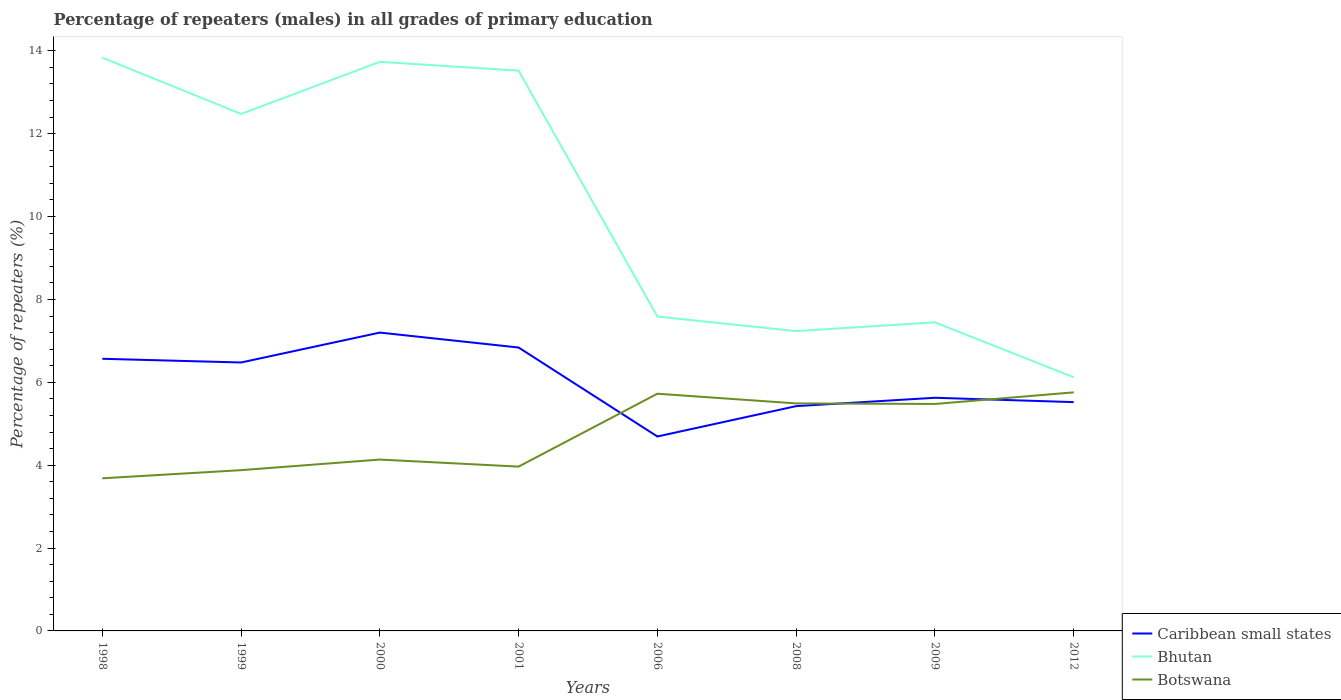How many different coloured lines are there?
Your answer should be compact. 3. Does the line corresponding to Botswana intersect with the line corresponding to Caribbean small states?
Give a very brief answer. Yes. Is the number of lines equal to the number of legend labels?
Make the answer very short. Yes. Across all years, what is the maximum percentage of repeaters (males) in Bhutan?
Keep it short and to the point. 6.12. What is the total percentage of repeaters (males) in Botswana in the graph?
Give a very brief answer. -1.79. What is the difference between the highest and the second highest percentage of repeaters (males) in Botswana?
Your answer should be very brief. 2.07. What is the difference between the highest and the lowest percentage of repeaters (males) in Caribbean small states?
Keep it short and to the point. 4. Is the percentage of repeaters (males) in Botswana strictly greater than the percentage of repeaters (males) in Bhutan over the years?
Provide a succinct answer. Yes. What is the difference between two consecutive major ticks on the Y-axis?
Provide a succinct answer. 2. Are the values on the major ticks of Y-axis written in scientific E-notation?
Offer a terse response. No. Does the graph contain any zero values?
Make the answer very short. No. Does the graph contain grids?
Make the answer very short. No. How many legend labels are there?
Ensure brevity in your answer.  3. How are the legend labels stacked?
Make the answer very short. Vertical. What is the title of the graph?
Keep it short and to the point. Percentage of repeaters (males) in all grades of primary education. Does "Kiribati" appear as one of the legend labels in the graph?
Provide a short and direct response. No. What is the label or title of the Y-axis?
Ensure brevity in your answer.  Percentage of repeaters (%). What is the Percentage of repeaters (%) of Caribbean small states in 1998?
Offer a terse response. 6.57. What is the Percentage of repeaters (%) of Bhutan in 1998?
Your answer should be very brief. 13.84. What is the Percentage of repeaters (%) in Botswana in 1998?
Keep it short and to the point. 3.68. What is the Percentage of repeaters (%) in Caribbean small states in 1999?
Your answer should be very brief. 6.48. What is the Percentage of repeaters (%) of Bhutan in 1999?
Ensure brevity in your answer.  12.48. What is the Percentage of repeaters (%) in Botswana in 1999?
Your answer should be very brief. 3.88. What is the Percentage of repeaters (%) in Caribbean small states in 2000?
Your answer should be compact. 7.2. What is the Percentage of repeaters (%) of Bhutan in 2000?
Offer a terse response. 13.73. What is the Percentage of repeaters (%) in Botswana in 2000?
Keep it short and to the point. 4.14. What is the Percentage of repeaters (%) of Caribbean small states in 2001?
Keep it short and to the point. 6.84. What is the Percentage of repeaters (%) in Bhutan in 2001?
Provide a short and direct response. 13.52. What is the Percentage of repeaters (%) in Botswana in 2001?
Give a very brief answer. 3.97. What is the Percentage of repeaters (%) in Caribbean small states in 2006?
Provide a succinct answer. 4.69. What is the Percentage of repeaters (%) in Bhutan in 2006?
Give a very brief answer. 7.59. What is the Percentage of repeaters (%) in Botswana in 2006?
Your response must be concise. 5.72. What is the Percentage of repeaters (%) in Caribbean small states in 2008?
Give a very brief answer. 5.42. What is the Percentage of repeaters (%) of Bhutan in 2008?
Make the answer very short. 7.24. What is the Percentage of repeaters (%) in Botswana in 2008?
Provide a short and direct response. 5.49. What is the Percentage of repeaters (%) in Caribbean small states in 2009?
Provide a short and direct response. 5.63. What is the Percentage of repeaters (%) of Bhutan in 2009?
Provide a short and direct response. 7.45. What is the Percentage of repeaters (%) of Botswana in 2009?
Provide a short and direct response. 5.48. What is the Percentage of repeaters (%) of Caribbean small states in 2012?
Provide a short and direct response. 5.52. What is the Percentage of repeaters (%) in Bhutan in 2012?
Your answer should be compact. 6.12. What is the Percentage of repeaters (%) of Botswana in 2012?
Provide a succinct answer. 5.76. Across all years, what is the maximum Percentage of repeaters (%) of Caribbean small states?
Give a very brief answer. 7.2. Across all years, what is the maximum Percentage of repeaters (%) in Bhutan?
Your answer should be compact. 13.84. Across all years, what is the maximum Percentage of repeaters (%) of Botswana?
Provide a succinct answer. 5.76. Across all years, what is the minimum Percentage of repeaters (%) of Caribbean small states?
Make the answer very short. 4.69. Across all years, what is the minimum Percentage of repeaters (%) in Bhutan?
Your answer should be very brief. 6.12. Across all years, what is the minimum Percentage of repeaters (%) in Botswana?
Provide a short and direct response. 3.68. What is the total Percentage of repeaters (%) of Caribbean small states in the graph?
Make the answer very short. 48.35. What is the total Percentage of repeaters (%) of Bhutan in the graph?
Ensure brevity in your answer.  81.96. What is the total Percentage of repeaters (%) in Botswana in the graph?
Keep it short and to the point. 38.11. What is the difference between the Percentage of repeaters (%) in Caribbean small states in 1998 and that in 1999?
Offer a very short reply. 0.09. What is the difference between the Percentage of repeaters (%) in Bhutan in 1998 and that in 1999?
Make the answer very short. 1.36. What is the difference between the Percentage of repeaters (%) in Botswana in 1998 and that in 1999?
Your answer should be compact. -0.2. What is the difference between the Percentage of repeaters (%) of Caribbean small states in 1998 and that in 2000?
Your response must be concise. -0.63. What is the difference between the Percentage of repeaters (%) in Bhutan in 1998 and that in 2000?
Give a very brief answer. 0.1. What is the difference between the Percentage of repeaters (%) in Botswana in 1998 and that in 2000?
Ensure brevity in your answer.  -0.45. What is the difference between the Percentage of repeaters (%) in Caribbean small states in 1998 and that in 2001?
Provide a short and direct response. -0.27. What is the difference between the Percentage of repeaters (%) of Bhutan in 1998 and that in 2001?
Ensure brevity in your answer.  0.31. What is the difference between the Percentage of repeaters (%) in Botswana in 1998 and that in 2001?
Keep it short and to the point. -0.28. What is the difference between the Percentage of repeaters (%) of Caribbean small states in 1998 and that in 2006?
Make the answer very short. 1.88. What is the difference between the Percentage of repeaters (%) of Bhutan in 1998 and that in 2006?
Your answer should be very brief. 6.25. What is the difference between the Percentage of repeaters (%) in Botswana in 1998 and that in 2006?
Your answer should be compact. -2.04. What is the difference between the Percentage of repeaters (%) in Caribbean small states in 1998 and that in 2008?
Keep it short and to the point. 1.14. What is the difference between the Percentage of repeaters (%) of Bhutan in 1998 and that in 2008?
Offer a terse response. 6.6. What is the difference between the Percentage of repeaters (%) in Botswana in 1998 and that in 2008?
Give a very brief answer. -1.81. What is the difference between the Percentage of repeaters (%) of Caribbean small states in 1998 and that in 2009?
Ensure brevity in your answer.  0.94. What is the difference between the Percentage of repeaters (%) of Bhutan in 1998 and that in 2009?
Keep it short and to the point. 6.39. What is the difference between the Percentage of repeaters (%) in Botswana in 1998 and that in 2009?
Give a very brief answer. -1.79. What is the difference between the Percentage of repeaters (%) in Caribbean small states in 1998 and that in 2012?
Provide a short and direct response. 1.05. What is the difference between the Percentage of repeaters (%) of Bhutan in 1998 and that in 2012?
Provide a short and direct response. 7.71. What is the difference between the Percentage of repeaters (%) of Botswana in 1998 and that in 2012?
Make the answer very short. -2.07. What is the difference between the Percentage of repeaters (%) in Caribbean small states in 1999 and that in 2000?
Offer a very short reply. -0.72. What is the difference between the Percentage of repeaters (%) of Bhutan in 1999 and that in 2000?
Ensure brevity in your answer.  -1.26. What is the difference between the Percentage of repeaters (%) of Botswana in 1999 and that in 2000?
Offer a terse response. -0.26. What is the difference between the Percentage of repeaters (%) of Caribbean small states in 1999 and that in 2001?
Your response must be concise. -0.36. What is the difference between the Percentage of repeaters (%) of Bhutan in 1999 and that in 2001?
Make the answer very short. -1.05. What is the difference between the Percentage of repeaters (%) in Botswana in 1999 and that in 2001?
Offer a terse response. -0.09. What is the difference between the Percentage of repeaters (%) in Caribbean small states in 1999 and that in 2006?
Offer a terse response. 1.79. What is the difference between the Percentage of repeaters (%) in Bhutan in 1999 and that in 2006?
Offer a terse response. 4.89. What is the difference between the Percentage of repeaters (%) of Botswana in 1999 and that in 2006?
Provide a succinct answer. -1.84. What is the difference between the Percentage of repeaters (%) in Caribbean small states in 1999 and that in 2008?
Offer a terse response. 1.05. What is the difference between the Percentage of repeaters (%) of Bhutan in 1999 and that in 2008?
Provide a succinct answer. 5.24. What is the difference between the Percentage of repeaters (%) in Botswana in 1999 and that in 2008?
Your response must be concise. -1.61. What is the difference between the Percentage of repeaters (%) in Caribbean small states in 1999 and that in 2009?
Make the answer very short. 0.85. What is the difference between the Percentage of repeaters (%) in Bhutan in 1999 and that in 2009?
Give a very brief answer. 5.03. What is the difference between the Percentage of repeaters (%) in Botswana in 1999 and that in 2009?
Offer a terse response. -1.6. What is the difference between the Percentage of repeaters (%) of Caribbean small states in 1999 and that in 2012?
Ensure brevity in your answer.  0.96. What is the difference between the Percentage of repeaters (%) in Bhutan in 1999 and that in 2012?
Ensure brevity in your answer.  6.35. What is the difference between the Percentage of repeaters (%) in Botswana in 1999 and that in 2012?
Ensure brevity in your answer.  -1.88. What is the difference between the Percentage of repeaters (%) in Caribbean small states in 2000 and that in 2001?
Offer a very short reply. 0.36. What is the difference between the Percentage of repeaters (%) of Bhutan in 2000 and that in 2001?
Give a very brief answer. 0.21. What is the difference between the Percentage of repeaters (%) of Botswana in 2000 and that in 2001?
Your answer should be very brief. 0.17. What is the difference between the Percentage of repeaters (%) in Caribbean small states in 2000 and that in 2006?
Provide a succinct answer. 2.51. What is the difference between the Percentage of repeaters (%) of Bhutan in 2000 and that in 2006?
Offer a very short reply. 6.15. What is the difference between the Percentage of repeaters (%) in Botswana in 2000 and that in 2006?
Your answer should be very brief. -1.59. What is the difference between the Percentage of repeaters (%) of Caribbean small states in 2000 and that in 2008?
Provide a succinct answer. 1.77. What is the difference between the Percentage of repeaters (%) of Bhutan in 2000 and that in 2008?
Offer a very short reply. 6.5. What is the difference between the Percentage of repeaters (%) in Botswana in 2000 and that in 2008?
Your answer should be very brief. -1.35. What is the difference between the Percentage of repeaters (%) of Caribbean small states in 2000 and that in 2009?
Provide a succinct answer. 1.57. What is the difference between the Percentage of repeaters (%) in Bhutan in 2000 and that in 2009?
Provide a succinct answer. 6.29. What is the difference between the Percentage of repeaters (%) in Botswana in 2000 and that in 2009?
Offer a terse response. -1.34. What is the difference between the Percentage of repeaters (%) in Caribbean small states in 2000 and that in 2012?
Keep it short and to the point. 1.68. What is the difference between the Percentage of repeaters (%) in Bhutan in 2000 and that in 2012?
Make the answer very short. 7.61. What is the difference between the Percentage of repeaters (%) of Botswana in 2000 and that in 2012?
Offer a terse response. -1.62. What is the difference between the Percentage of repeaters (%) in Caribbean small states in 2001 and that in 2006?
Your response must be concise. 2.15. What is the difference between the Percentage of repeaters (%) of Bhutan in 2001 and that in 2006?
Provide a succinct answer. 5.93. What is the difference between the Percentage of repeaters (%) in Botswana in 2001 and that in 2006?
Keep it short and to the point. -1.76. What is the difference between the Percentage of repeaters (%) in Caribbean small states in 2001 and that in 2008?
Your answer should be compact. 1.41. What is the difference between the Percentage of repeaters (%) in Bhutan in 2001 and that in 2008?
Offer a very short reply. 6.29. What is the difference between the Percentage of repeaters (%) of Botswana in 2001 and that in 2008?
Offer a terse response. -1.52. What is the difference between the Percentage of repeaters (%) of Caribbean small states in 2001 and that in 2009?
Your answer should be very brief. 1.21. What is the difference between the Percentage of repeaters (%) in Bhutan in 2001 and that in 2009?
Offer a very short reply. 6.07. What is the difference between the Percentage of repeaters (%) in Botswana in 2001 and that in 2009?
Provide a succinct answer. -1.51. What is the difference between the Percentage of repeaters (%) of Caribbean small states in 2001 and that in 2012?
Ensure brevity in your answer.  1.32. What is the difference between the Percentage of repeaters (%) in Bhutan in 2001 and that in 2012?
Ensure brevity in your answer.  7.4. What is the difference between the Percentage of repeaters (%) in Botswana in 2001 and that in 2012?
Keep it short and to the point. -1.79. What is the difference between the Percentage of repeaters (%) in Caribbean small states in 2006 and that in 2008?
Offer a terse response. -0.73. What is the difference between the Percentage of repeaters (%) of Bhutan in 2006 and that in 2008?
Offer a terse response. 0.35. What is the difference between the Percentage of repeaters (%) of Botswana in 2006 and that in 2008?
Ensure brevity in your answer.  0.23. What is the difference between the Percentage of repeaters (%) of Caribbean small states in 2006 and that in 2009?
Your answer should be very brief. -0.93. What is the difference between the Percentage of repeaters (%) in Bhutan in 2006 and that in 2009?
Offer a very short reply. 0.14. What is the difference between the Percentage of repeaters (%) in Botswana in 2006 and that in 2009?
Make the answer very short. 0.25. What is the difference between the Percentage of repeaters (%) of Caribbean small states in 2006 and that in 2012?
Keep it short and to the point. -0.83. What is the difference between the Percentage of repeaters (%) of Bhutan in 2006 and that in 2012?
Your answer should be compact. 1.47. What is the difference between the Percentage of repeaters (%) in Botswana in 2006 and that in 2012?
Give a very brief answer. -0.03. What is the difference between the Percentage of repeaters (%) of Caribbean small states in 2008 and that in 2009?
Your response must be concise. -0.2. What is the difference between the Percentage of repeaters (%) in Bhutan in 2008 and that in 2009?
Offer a terse response. -0.21. What is the difference between the Percentage of repeaters (%) in Botswana in 2008 and that in 2009?
Give a very brief answer. 0.01. What is the difference between the Percentage of repeaters (%) of Caribbean small states in 2008 and that in 2012?
Your answer should be very brief. -0.1. What is the difference between the Percentage of repeaters (%) of Bhutan in 2008 and that in 2012?
Offer a terse response. 1.11. What is the difference between the Percentage of repeaters (%) in Botswana in 2008 and that in 2012?
Your answer should be compact. -0.27. What is the difference between the Percentage of repeaters (%) in Caribbean small states in 2009 and that in 2012?
Your response must be concise. 0.1. What is the difference between the Percentage of repeaters (%) of Bhutan in 2009 and that in 2012?
Ensure brevity in your answer.  1.33. What is the difference between the Percentage of repeaters (%) of Botswana in 2009 and that in 2012?
Your answer should be compact. -0.28. What is the difference between the Percentage of repeaters (%) of Caribbean small states in 1998 and the Percentage of repeaters (%) of Bhutan in 1999?
Provide a short and direct response. -5.91. What is the difference between the Percentage of repeaters (%) of Caribbean small states in 1998 and the Percentage of repeaters (%) of Botswana in 1999?
Offer a terse response. 2.69. What is the difference between the Percentage of repeaters (%) of Bhutan in 1998 and the Percentage of repeaters (%) of Botswana in 1999?
Make the answer very short. 9.96. What is the difference between the Percentage of repeaters (%) in Caribbean small states in 1998 and the Percentage of repeaters (%) in Bhutan in 2000?
Make the answer very short. -7.17. What is the difference between the Percentage of repeaters (%) of Caribbean small states in 1998 and the Percentage of repeaters (%) of Botswana in 2000?
Your answer should be compact. 2.43. What is the difference between the Percentage of repeaters (%) in Bhutan in 1998 and the Percentage of repeaters (%) in Botswana in 2000?
Make the answer very short. 9.7. What is the difference between the Percentage of repeaters (%) in Caribbean small states in 1998 and the Percentage of repeaters (%) in Bhutan in 2001?
Offer a terse response. -6.95. What is the difference between the Percentage of repeaters (%) in Caribbean small states in 1998 and the Percentage of repeaters (%) in Botswana in 2001?
Your response must be concise. 2.6. What is the difference between the Percentage of repeaters (%) in Bhutan in 1998 and the Percentage of repeaters (%) in Botswana in 2001?
Provide a succinct answer. 9.87. What is the difference between the Percentage of repeaters (%) in Caribbean small states in 1998 and the Percentage of repeaters (%) in Bhutan in 2006?
Keep it short and to the point. -1.02. What is the difference between the Percentage of repeaters (%) of Caribbean small states in 1998 and the Percentage of repeaters (%) of Botswana in 2006?
Offer a terse response. 0.84. What is the difference between the Percentage of repeaters (%) of Bhutan in 1998 and the Percentage of repeaters (%) of Botswana in 2006?
Keep it short and to the point. 8.11. What is the difference between the Percentage of repeaters (%) in Caribbean small states in 1998 and the Percentage of repeaters (%) in Bhutan in 2008?
Offer a very short reply. -0.67. What is the difference between the Percentage of repeaters (%) in Caribbean small states in 1998 and the Percentage of repeaters (%) in Botswana in 2008?
Keep it short and to the point. 1.08. What is the difference between the Percentage of repeaters (%) in Bhutan in 1998 and the Percentage of repeaters (%) in Botswana in 2008?
Your response must be concise. 8.35. What is the difference between the Percentage of repeaters (%) in Caribbean small states in 1998 and the Percentage of repeaters (%) in Bhutan in 2009?
Ensure brevity in your answer.  -0.88. What is the difference between the Percentage of repeaters (%) in Caribbean small states in 1998 and the Percentage of repeaters (%) in Botswana in 2009?
Offer a very short reply. 1.09. What is the difference between the Percentage of repeaters (%) of Bhutan in 1998 and the Percentage of repeaters (%) of Botswana in 2009?
Your answer should be very brief. 8.36. What is the difference between the Percentage of repeaters (%) of Caribbean small states in 1998 and the Percentage of repeaters (%) of Bhutan in 2012?
Keep it short and to the point. 0.45. What is the difference between the Percentage of repeaters (%) in Caribbean small states in 1998 and the Percentage of repeaters (%) in Botswana in 2012?
Provide a short and direct response. 0.81. What is the difference between the Percentage of repeaters (%) of Bhutan in 1998 and the Percentage of repeaters (%) of Botswana in 2012?
Keep it short and to the point. 8.08. What is the difference between the Percentage of repeaters (%) in Caribbean small states in 1999 and the Percentage of repeaters (%) in Bhutan in 2000?
Give a very brief answer. -7.26. What is the difference between the Percentage of repeaters (%) in Caribbean small states in 1999 and the Percentage of repeaters (%) in Botswana in 2000?
Your answer should be very brief. 2.34. What is the difference between the Percentage of repeaters (%) in Bhutan in 1999 and the Percentage of repeaters (%) in Botswana in 2000?
Provide a short and direct response. 8.34. What is the difference between the Percentage of repeaters (%) in Caribbean small states in 1999 and the Percentage of repeaters (%) in Bhutan in 2001?
Provide a short and direct response. -7.04. What is the difference between the Percentage of repeaters (%) of Caribbean small states in 1999 and the Percentage of repeaters (%) of Botswana in 2001?
Provide a short and direct response. 2.51. What is the difference between the Percentage of repeaters (%) of Bhutan in 1999 and the Percentage of repeaters (%) of Botswana in 2001?
Your answer should be very brief. 8.51. What is the difference between the Percentage of repeaters (%) in Caribbean small states in 1999 and the Percentage of repeaters (%) in Bhutan in 2006?
Ensure brevity in your answer.  -1.11. What is the difference between the Percentage of repeaters (%) of Caribbean small states in 1999 and the Percentage of repeaters (%) of Botswana in 2006?
Your response must be concise. 0.75. What is the difference between the Percentage of repeaters (%) of Bhutan in 1999 and the Percentage of repeaters (%) of Botswana in 2006?
Your answer should be very brief. 6.75. What is the difference between the Percentage of repeaters (%) in Caribbean small states in 1999 and the Percentage of repeaters (%) in Bhutan in 2008?
Ensure brevity in your answer.  -0.76. What is the difference between the Percentage of repeaters (%) of Caribbean small states in 1999 and the Percentage of repeaters (%) of Botswana in 2008?
Give a very brief answer. 0.99. What is the difference between the Percentage of repeaters (%) of Bhutan in 1999 and the Percentage of repeaters (%) of Botswana in 2008?
Keep it short and to the point. 6.99. What is the difference between the Percentage of repeaters (%) of Caribbean small states in 1999 and the Percentage of repeaters (%) of Bhutan in 2009?
Ensure brevity in your answer.  -0.97. What is the difference between the Percentage of repeaters (%) of Caribbean small states in 1999 and the Percentage of repeaters (%) of Botswana in 2009?
Provide a succinct answer. 1. What is the difference between the Percentage of repeaters (%) of Bhutan in 1999 and the Percentage of repeaters (%) of Botswana in 2009?
Ensure brevity in your answer.  7. What is the difference between the Percentage of repeaters (%) of Caribbean small states in 1999 and the Percentage of repeaters (%) of Bhutan in 2012?
Keep it short and to the point. 0.36. What is the difference between the Percentage of repeaters (%) of Caribbean small states in 1999 and the Percentage of repeaters (%) of Botswana in 2012?
Offer a very short reply. 0.72. What is the difference between the Percentage of repeaters (%) of Bhutan in 1999 and the Percentage of repeaters (%) of Botswana in 2012?
Ensure brevity in your answer.  6.72. What is the difference between the Percentage of repeaters (%) of Caribbean small states in 2000 and the Percentage of repeaters (%) of Bhutan in 2001?
Your response must be concise. -6.32. What is the difference between the Percentage of repeaters (%) of Caribbean small states in 2000 and the Percentage of repeaters (%) of Botswana in 2001?
Provide a succinct answer. 3.23. What is the difference between the Percentage of repeaters (%) in Bhutan in 2000 and the Percentage of repeaters (%) in Botswana in 2001?
Give a very brief answer. 9.77. What is the difference between the Percentage of repeaters (%) of Caribbean small states in 2000 and the Percentage of repeaters (%) of Bhutan in 2006?
Offer a terse response. -0.39. What is the difference between the Percentage of repeaters (%) in Caribbean small states in 2000 and the Percentage of repeaters (%) in Botswana in 2006?
Provide a succinct answer. 1.48. What is the difference between the Percentage of repeaters (%) in Bhutan in 2000 and the Percentage of repeaters (%) in Botswana in 2006?
Offer a terse response. 8.01. What is the difference between the Percentage of repeaters (%) in Caribbean small states in 2000 and the Percentage of repeaters (%) in Bhutan in 2008?
Keep it short and to the point. -0.04. What is the difference between the Percentage of repeaters (%) in Caribbean small states in 2000 and the Percentage of repeaters (%) in Botswana in 2008?
Offer a very short reply. 1.71. What is the difference between the Percentage of repeaters (%) in Bhutan in 2000 and the Percentage of repeaters (%) in Botswana in 2008?
Your response must be concise. 8.24. What is the difference between the Percentage of repeaters (%) in Caribbean small states in 2000 and the Percentage of repeaters (%) in Bhutan in 2009?
Your response must be concise. -0.25. What is the difference between the Percentage of repeaters (%) of Caribbean small states in 2000 and the Percentage of repeaters (%) of Botswana in 2009?
Make the answer very short. 1.72. What is the difference between the Percentage of repeaters (%) of Bhutan in 2000 and the Percentage of repeaters (%) of Botswana in 2009?
Ensure brevity in your answer.  8.26. What is the difference between the Percentage of repeaters (%) in Caribbean small states in 2000 and the Percentage of repeaters (%) in Bhutan in 2012?
Your response must be concise. 1.08. What is the difference between the Percentage of repeaters (%) of Caribbean small states in 2000 and the Percentage of repeaters (%) of Botswana in 2012?
Your answer should be compact. 1.44. What is the difference between the Percentage of repeaters (%) in Bhutan in 2000 and the Percentage of repeaters (%) in Botswana in 2012?
Offer a very short reply. 7.98. What is the difference between the Percentage of repeaters (%) of Caribbean small states in 2001 and the Percentage of repeaters (%) of Bhutan in 2006?
Your response must be concise. -0.75. What is the difference between the Percentage of repeaters (%) in Caribbean small states in 2001 and the Percentage of repeaters (%) in Botswana in 2006?
Your response must be concise. 1.11. What is the difference between the Percentage of repeaters (%) in Bhutan in 2001 and the Percentage of repeaters (%) in Botswana in 2006?
Offer a terse response. 7.8. What is the difference between the Percentage of repeaters (%) in Caribbean small states in 2001 and the Percentage of repeaters (%) in Bhutan in 2008?
Provide a succinct answer. -0.4. What is the difference between the Percentage of repeaters (%) of Caribbean small states in 2001 and the Percentage of repeaters (%) of Botswana in 2008?
Give a very brief answer. 1.35. What is the difference between the Percentage of repeaters (%) of Bhutan in 2001 and the Percentage of repeaters (%) of Botswana in 2008?
Your response must be concise. 8.03. What is the difference between the Percentage of repeaters (%) in Caribbean small states in 2001 and the Percentage of repeaters (%) in Bhutan in 2009?
Provide a succinct answer. -0.61. What is the difference between the Percentage of repeaters (%) in Caribbean small states in 2001 and the Percentage of repeaters (%) in Botswana in 2009?
Give a very brief answer. 1.36. What is the difference between the Percentage of repeaters (%) of Bhutan in 2001 and the Percentage of repeaters (%) of Botswana in 2009?
Offer a very short reply. 8.04. What is the difference between the Percentage of repeaters (%) of Caribbean small states in 2001 and the Percentage of repeaters (%) of Bhutan in 2012?
Provide a short and direct response. 0.72. What is the difference between the Percentage of repeaters (%) in Caribbean small states in 2001 and the Percentage of repeaters (%) in Botswana in 2012?
Offer a terse response. 1.08. What is the difference between the Percentage of repeaters (%) in Bhutan in 2001 and the Percentage of repeaters (%) in Botswana in 2012?
Provide a succinct answer. 7.76. What is the difference between the Percentage of repeaters (%) in Caribbean small states in 2006 and the Percentage of repeaters (%) in Bhutan in 2008?
Offer a terse response. -2.54. What is the difference between the Percentage of repeaters (%) in Caribbean small states in 2006 and the Percentage of repeaters (%) in Botswana in 2008?
Offer a very short reply. -0.8. What is the difference between the Percentage of repeaters (%) of Bhutan in 2006 and the Percentage of repeaters (%) of Botswana in 2008?
Keep it short and to the point. 2.1. What is the difference between the Percentage of repeaters (%) in Caribbean small states in 2006 and the Percentage of repeaters (%) in Bhutan in 2009?
Give a very brief answer. -2.76. What is the difference between the Percentage of repeaters (%) in Caribbean small states in 2006 and the Percentage of repeaters (%) in Botswana in 2009?
Your answer should be compact. -0.79. What is the difference between the Percentage of repeaters (%) in Bhutan in 2006 and the Percentage of repeaters (%) in Botswana in 2009?
Offer a very short reply. 2.11. What is the difference between the Percentage of repeaters (%) in Caribbean small states in 2006 and the Percentage of repeaters (%) in Bhutan in 2012?
Your response must be concise. -1.43. What is the difference between the Percentage of repeaters (%) in Caribbean small states in 2006 and the Percentage of repeaters (%) in Botswana in 2012?
Provide a succinct answer. -1.07. What is the difference between the Percentage of repeaters (%) in Bhutan in 2006 and the Percentage of repeaters (%) in Botswana in 2012?
Make the answer very short. 1.83. What is the difference between the Percentage of repeaters (%) in Caribbean small states in 2008 and the Percentage of repeaters (%) in Bhutan in 2009?
Ensure brevity in your answer.  -2.02. What is the difference between the Percentage of repeaters (%) of Caribbean small states in 2008 and the Percentage of repeaters (%) of Botswana in 2009?
Your answer should be very brief. -0.05. What is the difference between the Percentage of repeaters (%) of Bhutan in 2008 and the Percentage of repeaters (%) of Botswana in 2009?
Your answer should be compact. 1.76. What is the difference between the Percentage of repeaters (%) of Caribbean small states in 2008 and the Percentage of repeaters (%) of Bhutan in 2012?
Ensure brevity in your answer.  -0.7. What is the difference between the Percentage of repeaters (%) of Caribbean small states in 2008 and the Percentage of repeaters (%) of Botswana in 2012?
Your response must be concise. -0.33. What is the difference between the Percentage of repeaters (%) of Bhutan in 2008 and the Percentage of repeaters (%) of Botswana in 2012?
Keep it short and to the point. 1.48. What is the difference between the Percentage of repeaters (%) in Caribbean small states in 2009 and the Percentage of repeaters (%) in Bhutan in 2012?
Your response must be concise. -0.49. What is the difference between the Percentage of repeaters (%) of Caribbean small states in 2009 and the Percentage of repeaters (%) of Botswana in 2012?
Provide a succinct answer. -0.13. What is the difference between the Percentage of repeaters (%) in Bhutan in 2009 and the Percentage of repeaters (%) in Botswana in 2012?
Your answer should be compact. 1.69. What is the average Percentage of repeaters (%) of Caribbean small states per year?
Make the answer very short. 6.04. What is the average Percentage of repeaters (%) in Bhutan per year?
Provide a short and direct response. 10.24. What is the average Percentage of repeaters (%) in Botswana per year?
Keep it short and to the point. 4.76. In the year 1998, what is the difference between the Percentage of repeaters (%) in Caribbean small states and Percentage of repeaters (%) in Bhutan?
Offer a terse response. -7.27. In the year 1998, what is the difference between the Percentage of repeaters (%) in Caribbean small states and Percentage of repeaters (%) in Botswana?
Keep it short and to the point. 2.88. In the year 1998, what is the difference between the Percentage of repeaters (%) in Bhutan and Percentage of repeaters (%) in Botswana?
Ensure brevity in your answer.  10.15. In the year 1999, what is the difference between the Percentage of repeaters (%) of Caribbean small states and Percentage of repeaters (%) of Bhutan?
Offer a very short reply. -6. In the year 1999, what is the difference between the Percentage of repeaters (%) in Caribbean small states and Percentage of repeaters (%) in Botswana?
Give a very brief answer. 2.6. In the year 1999, what is the difference between the Percentage of repeaters (%) of Bhutan and Percentage of repeaters (%) of Botswana?
Offer a terse response. 8.6. In the year 2000, what is the difference between the Percentage of repeaters (%) of Caribbean small states and Percentage of repeaters (%) of Bhutan?
Your answer should be very brief. -6.53. In the year 2000, what is the difference between the Percentage of repeaters (%) in Caribbean small states and Percentage of repeaters (%) in Botswana?
Your response must be concise. 3.06. In the year 2000, what is the difference between the Percentage of repeaters (%) of Bhutan and Percentage of repeaters (%) of Botswana?
Your answer should be compact. 9.6. In the year 2001, what is the difference between the Percentage of repeaters (%) in Caribbean small states and Percentage of repeaters (%) in Bhutan?
Provide a short and direct response. -6.68. In the year 2001, what is the difference between the Percentage of repeaters (%) of Caribbean small states and Percentage of repeaters (%) of Botswana?
Ensure brevity in your answer.  2.87. In the year 2001, what is the difference between the Percentage of repeaters (%) in Bhutan and Percentage of repeaters (%) in Botswana?
Provide a short and direct response. 9.56. In the year 2006, what is the difference between the Percentage of repeaters (%) in Caribbean small states and Percentage of repeaters (%) in Bhutan?
Offer a very short reply. -2.89. In the year 2006, what is the difference between the Percentage of repeaters (%) in Caribbean small states and Percentage of repeaters (%) in Botswana?
Provide a short and direct response. -1.03. In the year 2006, what is the difference between the Percentage of repeaters (%) in Bhutan and Percentage of repeaters (%) in Botswana?
Offer a terse response. 1.86. In the year 2008, what is the difference between the Percentage of repeaters (%) in Caribbean small states and Percentage of repeaters (%) in Bhutan?
Keep it short and to the point. -1.81. In the year 2008, what is the difference between the Percentage of repeaters (%) in Caribbean small states and Percentage of repeaters (%) in Botswana?
Offer a very short reply. -0.07. In the year 2008, what is the difference between the Percentage of repeaters (%) in Bhutan and Percentage of repeaters (%) in Botswana?
Your answer should be very brief. 1.74. In the year 2009, what is the difference between the Percentage of repeaters (%) of Caribbean small states and Percentage of repeaters (%) of Bhutan?
Give a very brief answer. -1.82. In the year 2009, what is the difference between the Percentage of repeaters (%) of Caribbean small states and Percentage of repeaters (%) of Botswana?
Your response must be concise. 0.15. In the year 2009, what is the difference between the Percentage of repeaters (%) in Bhutan and Percentage of repeaters (%) in Botswana?
Make the answer very short. 1.97. In the year 2012, what is the difference between the Percentage of repeaters (%) in Caribbean small states and Percentage of repeaters (%) in Bhutan?
Provide a short and direct response. -0.6. In the year 2012, what is the difference between the Percentage of repeaters (%) in Caribbean small states and Percentage of repeaters (%) in Botswana?
Provide a short and direct response. -0.24. In the year 2012, what is the difference between the Percentage of repeaters (%) in Bhutan and Percentage of repeaters (%) in Botswana?
Ensure brevity in your answer.  0.36. What is the ratio of the Percentage of repeaters (%) of Caribbean small states in 1998 to that in 1999?
Your response must be concise. 1.01. What is the ratio of the Percentage of repeaters (%) in Bhutan in 1998 to that in 1999?
Keep it short and to the point. 1.11. What is the ratio of the Percentage of repeaters (%) in Botswana in 1998 to that in 1999?
Give a very brief answer. 0.95. What is the ratio of the Percentage of repeaters (%) of Caribbean small states in 1998 to that in 2000?
Provide a short and direct response. 0.91. What is the ratio of the Percentage of repeaters (%) of Bhutan in 1998 to that in 2000?
Your answer should be compact. 1.01. What is the ratio of the Percentage of repeaters (%) of Botswana in 1998 to that in 2000?
Provide a succinct answer. 0.89. What is the ratio of the Percentage of repeaters (%) in Caribbean small states in 1998 to that in 2001?
Your response must be concise. 0.96. What is the ratio of the Percentage of repeaters (%) of Bhutan in 1998 to that in 2001?
Your answer should be compact. 1.02. What is the ratio of the Percentage of repeaters (%) of Botswana in 1998 to that in 2001?
Keep it short and to the point. 0.93. What is the ratio of the Percentage of repeaters (%) in Caribbean small states in 1998 to that in 2006?
Provide a short and direct response. 1.4. What is the ratio of the Percentage of repeaters (%) of Bhutan in 1998 to that in 2006?
Your answer should be very brief. 1.82. What is the ratio of the Percentage of repeaters (%) of Botswana in 1998 to that in 2006?
Keep it short and to the point. 0.64. What is the ratio of the Percentage of repeaters (%) of Caribbean small states in 1998 to that in 2008?
Ensure brevity in your answer.  1.21. What is the ratio of the Percentage of repeaters (%) in Bhutan in 1998 to that in 2008?
Provide a succinct answer. 1.91. What is the ratio of the Percentage of repeaters (%) of Botswana in 1998 to that in 2008?
Give a very brief answer. 0.67. What is the ratio of the Percentage of repeaters (%) in Caribbean small states in 1998 to that in 2009?
Your response must be concise. 1.17. What is the ratio of the Percentage of repeaters (%) of Bhutan in 1998 to that in 2009?
Give a very brief answer. 1.86. What is the ratio of the Percentage of repeaters (%) in Botswana in 1998 to that in 2009?
Ensure brevity in your answer.  0.67. What is the ratio of the Percentage of repeaters (%) in Caribbean small states in 1998 to that in 2012?
Ensure brevity in your answer.  1.19. What is the ratio of the Percentage of repeaters (%) in Bhutan in 1998 to that in 2012?
Your answer should be compact. 2.26. What is the ratio of the Percentage of repeaters (%) in Botswana in 1998 to that in 2012?
Make the answer very short. 0.64. What is the ratio of the Percentage of repeaters (%) of Caribbean small states in 1999 to that in 2000?
Provide a succinct answer. 0.9. What is the ratio of the Percentage of repeaters (%) of Bhutan in 1999 to that in 2000?
Your response must be concise. 0.91. What is the ratio of the Percentage of repeaters (%) in Botswana in 1999 to that in 2000?
Keep it short and to the point. 0.94. What is the ratio of the Percentage of repeaters (%) in Caribbean small states in 1999 to that in 2001?
Provide a succinct answer. 0.95. What is the ratio of the Percentage of repeaters (%) of Bhutan in 1999 to that in 2001?
Ensure brevity in your answer.  0.92. What is the ratio of the Percentage of repeaters (%) in Botswana in 1999 to that in 2001?
Your response must be concise. 0.98. What is the ratio of the Percentage of repeaters (%) in Caribbean small states in 1999 to that in 2006?
Provide a short and direct response. 1.38. What is the ratio of the Percentage of repeaters (%) in Bhutan in 1999 to that in 2006?
Provide a short and direct response. 1.64. What is the ratio of the Percentage of repeaters (%) of Botswana in 1999 to that in 2006?
Your answer should be very brief. 0.68. What is the ratio of the Percentage of repeaters (%) of Caribbean small states in 1999 to that in 2008?
Provide a succinct answer. 1.19. What is the ratio of the Percentage of repeaters (%) in Bhutan in 1999 to that in 2008?
Offer a very short reply. 1.72. What is the ratio of the Percentage of repeaters (%) in Botswana in 1999 to that in 2008?
Keep it short and to the point. 0.71. What is the ratio of the Percentage of repeaters (%) in Caribbean small states in 1999 to that in 2009?
Make the answer very short. 1.15. What is the ratio of the Percentage of repeaters (%) in Bhutan in 1999 to that in 2009?
Offer a terse response. 1.68. What is the ratio of the Percentage of repeaters (%) of Botswana in 1999 to that in 2009?
Offer a very short reply. 0.71. What is the ratio of the Percentage of repeaters (%) in Caribbean small states in 1999 to that in 2012?
Offer a very short reply. 1.17. What is the ratio of the Percentage of repeaters (%) of Bhutan in 1999 to that in 2012?
Your answer should be compact. 2.04. What is the ratio of the Percentage of repeaters (%) in Botswana in 1999 to that in 2012?
Make the answer very short. 0.67. What is the ratio of the Percentage of repeaters (%) in Caribbean small states in 2000 to that in 2001?
Provide a succinct answer. 1.05. What is the ratio of the Percentage of repeaters (%) of Bhutan in 2000 to that in 2001?
Ensure brevity in your answer.  1.02. What is the ratio of the Percentage of repeaters (%) of Botswana in 2000 to that in 2001?
Give a very brief answer. 1.04. What is the ratio of the Percentage of repeaters (%) of Caribbean small states in 2000 to that in 2006?
Offer a terse response. 1.53. What is the ratio of the Percentage of repeaters (%) in Bhutan in 2000 to that in 2006?
Your answer should be compact. 1.81. What is the ratio of the Percentage of repeaters (%) of Botswana in 2000 to that in 2006?
Make the answer very short. 0.72. What is the ratio of the Percentage of repeaters (%) of Caribbean small states in 2000 to that in 2008?
Your response must be concise. 1.33. What is the ratio of the Percentage of repeaters (%) of Bhutan in 2000 to that in 2008?
Your response must be concise. 1.9. What is the ratio of the Percentage of repeaters (%) in Botswana in 2000 to that in 2008?
Your answer should be very brief. 0.75. What is the ratio of the Percentage of repeaters (%) of Caribbean small states in 2000 to that in 2009?
Your answer should be compact. 1.28. What is the ratio of the Percentage of repeaters (%) in Bhutan in 2000 to that in 2009?
Provide a short and direct response. 1.84. What is the ratio of the Percentage of repeaters (%) of Botswana in 2000 to that in 2009?
Provide a short and direct response. 0.76. What is the ratio of the Percentage of repeaters (%) of Caribbean small states in 2000 to that in 2012?
Provide a short and direct response. 1.3. What is the ratio of the Percentage of repeaters (%) in Bhutan in 2000 to that in 2012?
Provide a succinct answer. 2.24. What is the ratio of the Percentage of repeaters (%) of Botswana in 2000 to that in 2012?
Your response must be concise. 0.72. What is the ratio of the Percentage of repeaters (%) in Caribbean small states in 2001 to that in 2006?
Provide a succinct answer. 1.46. What is the ratio of the Percentage of repeaters (%) in Bhutan in 2001 to that in 2006?
Ensure brevity in your answer.  1.78. What is the ratio of the Percentage of repeaters (%) in Botswana in 2001 to that in 2006?
Keep it short and to the point. 0.69. What is the ratio of the Percentage of repeaters (%) in Caribbean small states in 2001 to that in 2008?
Keep it short and to the point. 1.26. What is the ratio of the Percentage of repeaters (%) in Bhutan in 2001 to that in 2008?
Keep it short and to the point. 1.87. What is the ratio of the Percentage of repeaters (%) of Botswana in 2001 to that in 2008?
Ensure brevity in your answer.  0.72. What is the ratio of the Percentage of repeaters (%) in Caribbean small states in 2001 to that in 2009?
Offer a very short reply. 1.22. What is the ratio of the Percentage of repeaters (%) of Bhutan in 2001 to that in 2009?
Make the answer very short. 1.82. What is the ratio of the Percentage of repeaters (%) of Botswana in 2001 to that in 2009?
Provide a short and direct response. 0.72. What is the ratio of the Percentage of repeaters (%) of Caribbean small states in 2001 to that in 2012?
Offer a very short reply. 1.24. What is the ratio of the Percentage of repeaters (%) of Bhutan in 2001 to that in 2012?
Your answer should be compact. 2.21. What is the ratio of the Percentage of repeaters (%) in Botswana in 2001 to that in 2012?
Provide a succinct answer. 0.69. What is the ratio of the Percentage of repeaters (%) in Caribbean small states in 2006 to that in 2008?
Your answer should be compact. 0.86. What is the ratio of the Percentage of repeaters (%) of Bhutan in 2006 to that in 2008?
Make the answer very short. 1.05. What is the ratio of the Percentage of repeaters (%) of Botswana in 2006 to that in 2008?
Offer a very short reply. 1.04. What is the ratio of the Percentage of repeaters (%) of Caribbean small states in 2006 to that in 2009?
Provide a short and direct response. 0.83. What is the ratio of the Percentage of repeaters (%) of Bhutan in 2006 to that in 2009?
Your response must be concise. 1.02. What is the ratio of the Percentage of repeaters (%) of Botswana in 2006 to that in 2009?
Ensure brevity in your answer.  1.05. What is the ratio of the Percentage of repeaters (%) in Caribbean small states in 2006 to that in 2012?
Make the answer very short. 0.85. What is the ratio of the Percentage of repeaters (%) of Bhutan in 2006 to that in 2012?
Provide a short and direct response. 1.24. What is the ratio of the Percentage of repeaters (%) in Botswana in 2006 to that in 2012?
Make the answer very short. 0.99. What is the ratio of the Percentage of repeaters (%) of Caribbean small states in 2008 to that in 2009?
Your response must be concise. 0.96. What is the ratio of the Percentage of repeaters (%) in Bhutan in 2008 to that in 2009?
Provide a succinct answer. 0.97. What is the ratio of the Percentage of repeaters (%) of Caribbean small states in 2008 to that in 2012?
Your response must be concise. 0.98. What is the ratio of the Percentage of repeaters (%) in Bhutan in 2008 to that in 2012?
Offer a terse response. 1.18. What is the ratio of the Percentage of repeaters (%) in Botswana in 2008 to that in 2012?
Give a very brief answer. 0.95. What is the ratio of the Percentage of repeaters (%) of Bhutan in 2009 to that in 2012?
Offer a terse response. 1.22. What is the ratio of the Percentage of repeaters (%) of Botswana in 2009 to that in 2012?
Your response must be concise. 0.95. What is the difference between the highest and the second highest Percentage of repeaters (%) of Caribbean small states?
Offer a very short reply. 0.36. What is the difference between the highest and the second highest Percentage of repeaters (%) in Bhutan?
Your answer should be compact. 0.1. What is the difference between the highest and the second highest Percentage of repeaters (%) of Botswana?
Your answer should be compact. 0.03. What is the difference between the highest and the lowest Percentage of repeaters (%) of Caribbean small states?
Your answer should be very brief. 2.51. What is the difference between the highest and the lowest Percentage of repeaters (%) in Bhutan?
Make the answer very short. 7.71. What is the difference between the highest and the lowest Percentage of repeaters (%) in Botswana?
Offer a terse response. 2.07. 